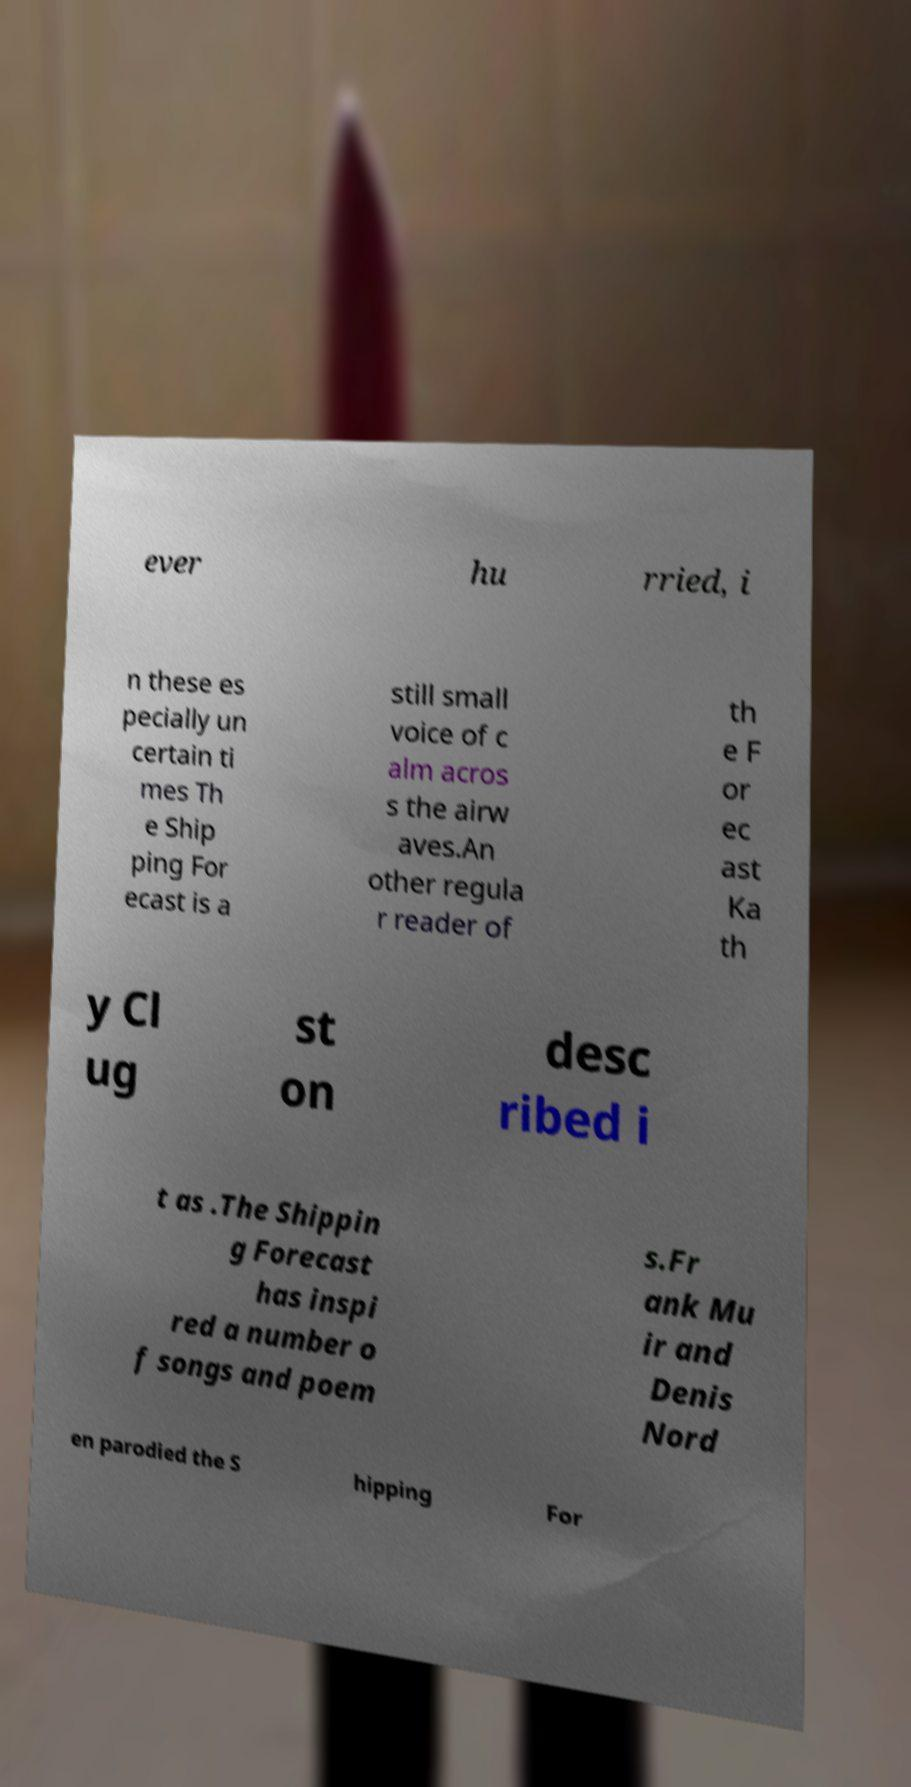Can you accurately transcribe the text from the provided image for me? ever hu rried, i n these es pecially un certain ti mes Th e Ship ping For ecast is a still small voice of c alm acros s the airw aves.An other regula r reader of th e F or ec ast Ka th y Cl ug st on desc ribed i t as .The Shippin g Forecast has inspi red a number o f songs and poem s.Fr ank Mu ir and Denis Nord en parodied the S hipping For 